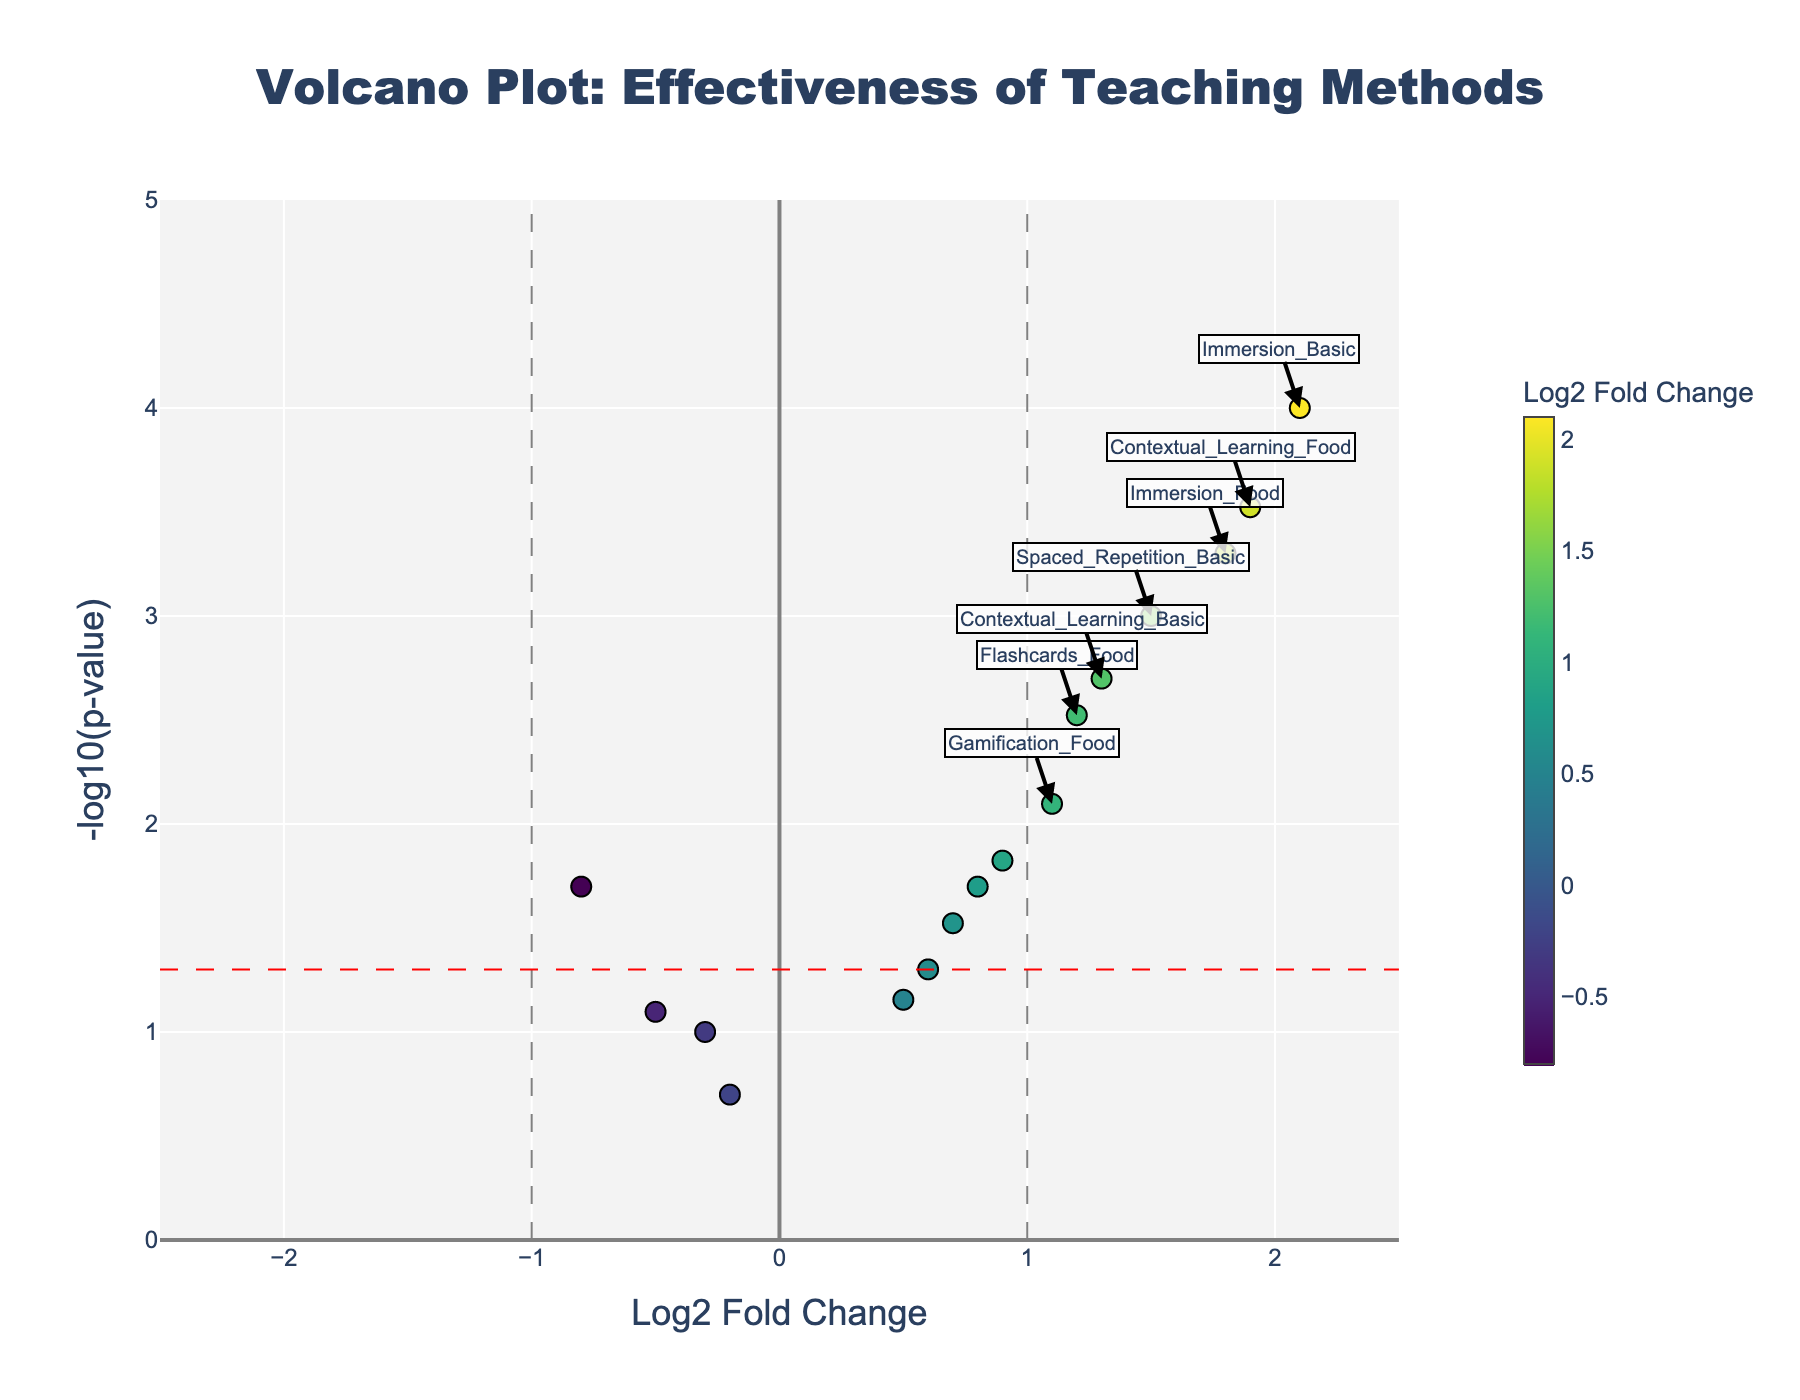What's the most effective method for teaching basic phrases based on the plot? The method with the highest Log2 Fold Change in the basic phrases category has the most effective outcome. According to the plot, Immersion_Basic has the highest Log2 Fold Change at 2.1.
Answer: Immersion_Basic Which teaching method has the least significant impact based on the p-value for food-related vocabulary? The method with the highest p-value for food-related vocabulary will have the least significant impact. Based on the plot, Mnemonic_Devices_Food has the highest p-value, indicated by a position close to the x-axis (lowest -log10(p-value)).
Answer: Mnemonic_Devices_Food How many methods show a significant effect (p < 0.05) for learning basic phrases? You need to count the number of points representing basic phrases that lie above the red horizontal line (-log10(0.05)). There are five such points: Flashcards_Basic, Immersion_Basic, Spaced_Repetition_Basic, Contextual_Learning_Basic, Gamification_Basic.
Answer: Five Which teaching method demonstrates the largest difference in effectiveness between basic phrases and food-related vocabulary? Determine the method with the highest absolute difference in Log2 Fold Change between basic phrases and food-related vocabulary categories. Immersion shows a large Log2 Fold Change difference between Immersion_Basic (2.1) and Immersion_Food (1.8), but the largest difference is Flashcards with Flashcards_Basic (-0.8) and Flashcards_Food (1.2), giving an absolute difference of 2.0.
Answer: Flashcards Which methods have a negative Log2 Fold Change for teaching basic phrases? Identify the points for basic phrases that fall to the left of the y-axis. Flashcards_Basic (-0.8), Audio_Lessons_Basic (-0.3), and Translation_Exercises_Basic (-0.5) have a negative Log2 Fold Change.
Answer: Flashcards_Basic, Audio_Lessons_Basic, Translation_Exercises_Basic What's the combined Log2 Fold Change for methods above 1 in basic phrases? Sum the Log2 Fold Change values of methods with Log2 Fold Change greater than 1 for basic phrases. These are Immersion_Basic (2.1), Spaced_Repetition_Basic (1.5), and Contextual_Learning_Basic (1.3). So the combined value is 2.1 + 1.5 + 1.3 = 4.9.
Answer: 4.9 Which method has the highest combined effectiveness for both basic phrases and food-related vocabulary? Calculate the sum of Log2 Fold Change values for each method in both categories and identify the highest value. For methods: Flashcards (1.2 - 0.8 = 0.4), Immersion (2.1 + 1.8 = 3.9), Spaced_Repetition (1.5 + 0.9 = 2.4), Audio_Lessons (-0.3 + 0.6 = 0.3), Gamification (0.7 + 1.1 = 1.8), Contextual_Learning (1.3 + 1.9 = 3.2), Mnemonic_Devices (0.5 - 0.2 = 0.3), Translation_Exercises (-0.5 + 0.8 = 0.3). Immersion has the highest combined Log2 Fold Change.
Answer: Immersion Which category (basic phrases or food-related vocabulary) generally shows higher significance overall in the methods? Assess which category has more points generally above the red horizontal line indicating p < 0.05 (higher -log10(p-value)). Observing the plot, both categories have several points above the threshold, but basic phrases have fewer points below the threshold, indicating generally higher significance.
Answer: Basic phrases What's the Log2 Fold Change and p-value of the most effective method for food-related vocabulary? The point with the highest Log2 Fold Change in the food-related vocabulary category and its corresponding p-value is needed. Contextual_Learning_Food with Log2 Fold Change of 1.9 and a p-value of 0.0003 is the most effective.
Answer: 1.9, 0.0003 